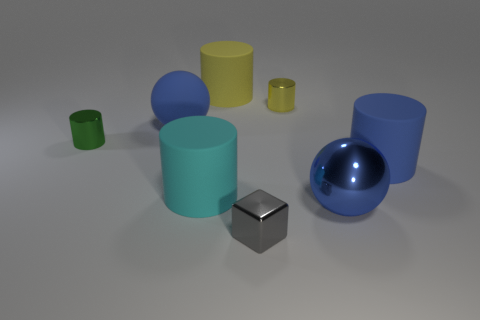Subtract all tiny green metallic cylinders. How many cylinders are left? 4 Subtract all blue cylinders. How many cylinders are left? 4 Subtract all purple cylinders. Subtract all red blocks. How many cylinders are left? 5 Add 1 cyan objects. How many objects exist? 9 Subtract all cylinders. How many objects are left? 3 Subtract all gray cubes. Subtract all green metallic cylinders. How many objects are left? 6 Add 1 gray cubes. How many gray cubes are left? 2 Add 5 blue matte cylinders. How many blue matte cylinders exist? 6 Subtract 0 gray spheres. How many objects are left? 8 